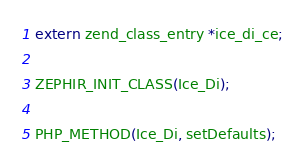<code> <loc_0><loc_0><loc_500><loc_500><_C_>
extern zend_class_entry *ice_di_ce;

ZEPHIR_INIT_CLASS(Ice_Di);

PHP_METHOD(Ice_Di, setDefaults);</code> 